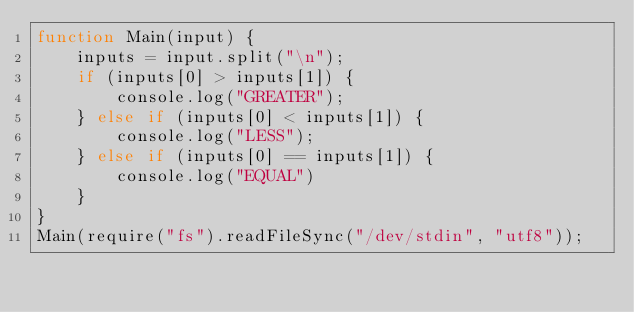<code> <loc_0><loc_0><loc_500><loc_500><_JavaScript_>function Main(input) {
    inputs = input.split("\n");
    if (inputs[0] > inputs[1]) {
        console.log("GREATER");
    } else if (inputs[0] < inputs[1]) {
        console.log("LESS");
    } else if (inputs[0] == inputs[1]) {
        console.log("EQUAL")
    }
}
Main(require("fs").readFileSync("/dev/stdin", "utf8"));</code> 